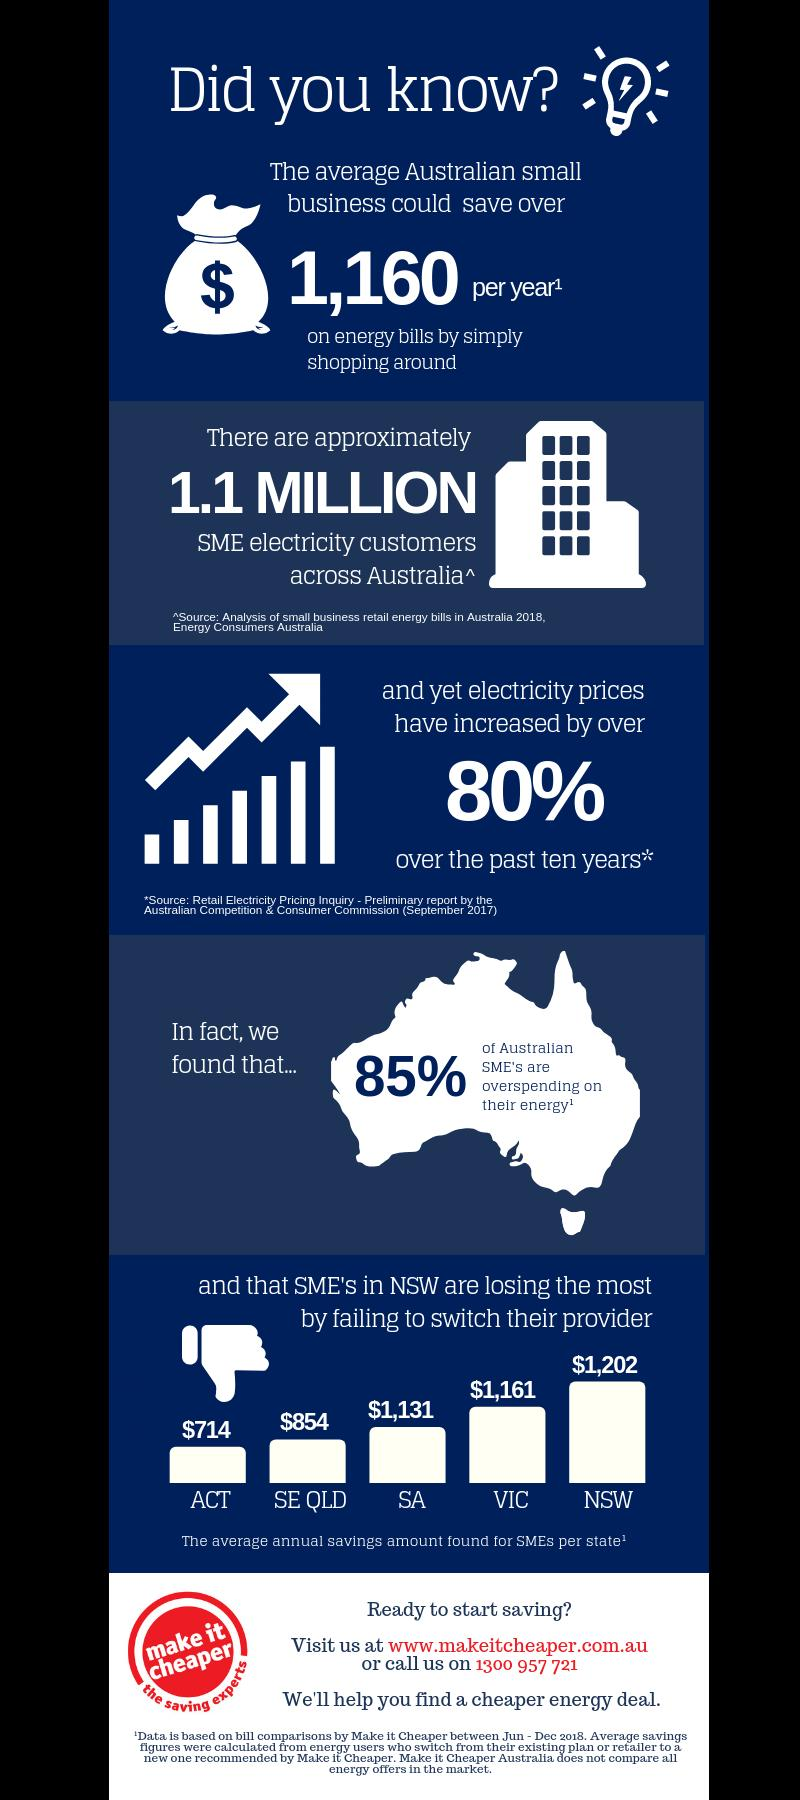Outline some significant characteristics in this image. The average annual savings amount in VIC is higher by $447 compared to ACT, According to the data, SMEs in ACT and SE QLD can expect to save an average of $1568 per year. The average annual savings amounts for SMEs in Australian states are shown, with the figure being 5. The total average annual savings amount for small and medium-sized enterprises (SMEs) in South Australia and Victoria is $2,292. South Australia has the third highest average annual savings amount for small and medium-sized enterprises (SMEs). 